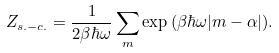<formula> <loc_0><loc_0><loc_500><loc_500>Z _ { s . - c . } = \frac { 1 } { 2 \beta \hbar { \omega } } \sum _ { m } \exp { ( \beta \hbar { \omega } { | m - \alpha | } ) } .</formula> 